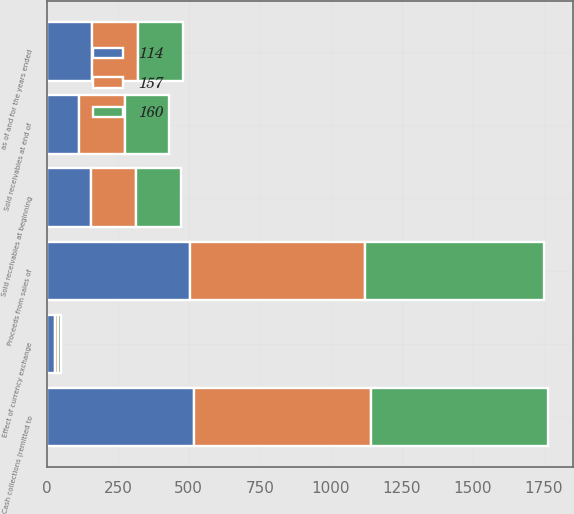<chart> <loc_0><loc_0><loc_500><loc_500><stacked_bar_chart><ecel><fcel>as of and for the years ended<fcel>Sold receivables at beginning<fcel>Proceeds from sales of<fcel>Cash collections (remitted to<fcel>Effect of currency exchange<fcel>Sold receivables at end of<nl><fcel>114<fcel>160<fcel>157<fcel>506<fcel>519<fcel>30<fcel>114<nl><fcel>160<fcel>160<fcel>160<fcel>630<fcel>624<fcel>9<fcel>157<nl><fcel>157<fcel>160<fcel>157<fcel>615<fcel>622<fcel>10<fcel>160<nl></chart> 